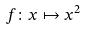Convert formula to latex. <formula><loc_0><loc_0><loc_500><loc_500>f \colon x \mapsto x ^ { 2 }</formula> 